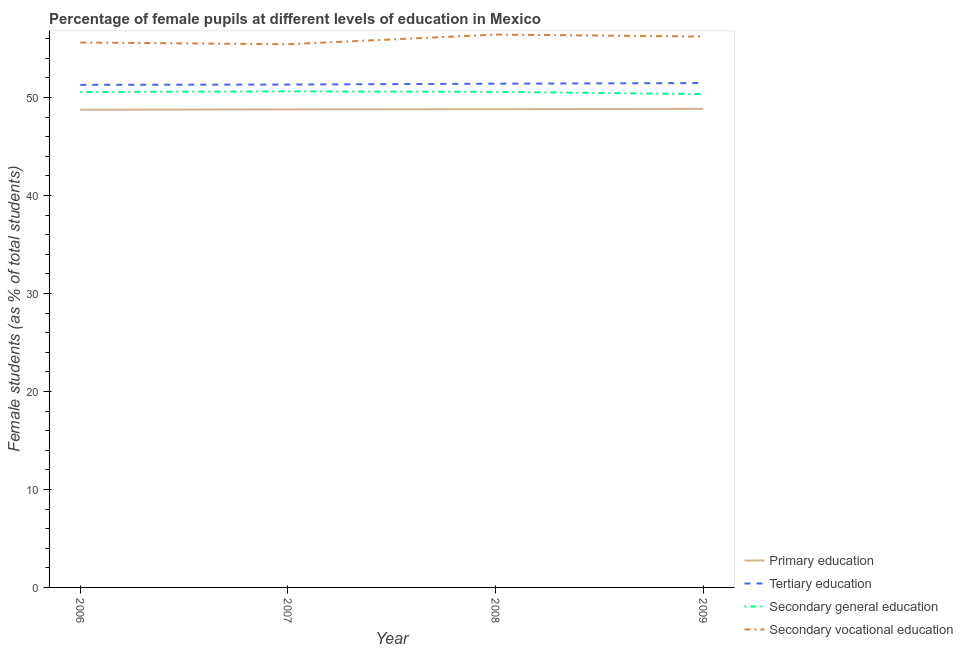How many different coloured lines are there?
Keep it short and to the point. 4. What is the percentage of female students in secondary education in 2008?
Provide a succinct answer. 50.57. Across all years, what is the maximum percentage of female students in tertiary education?
Provide a short and direct response. 51.46. Across all years, what is the minimum percentage of female students in secondary education?
Make the answer very short. 50.34. In which year was the percentage of female students in primary education maximum?
Provide a succinct answer. 2009. What is the total percentage of female students in tertiary education in the graph?
Offer a very short reply. 205.46. What is the difference between the percentage of female students in tertiary education in 2008 and that in 2009?
Make the answer very short. -0.07. What is the difference between the percentage of female students in primary education in 2006 and the percentage of female students in secondary vocational education in 2008?
Provide a short and direct response. -7.67. What is the average percentage of female students in tertiary education per year?
Your answer should be very brief. 51.36. In the year 2009, what is the difference between the percentage of female students in primary education and percentage of female students in secondary education?
Give a very brief answer. -1.51. In how many years, is the percentage of female students in secondary vocational education greater than 36 %?
Give a very brief answer. 4. What is the ratio of the percentage of female students in secondary education in 2007 to that in 2008?
Offer a terse response. 1. Is the difference between the percentage of female students in secondary vocational education in 2006 and 2007 greater than the difference between the percentage of female students in tertiary education in 2006 and 2007?
Your answer should be very brief. Yes. What is the difference between the highest and the second highest percentage of female students in tertiary education?
Ensure brevity in your answer.  0.07. What is the difference between the highest and the lowest percentage of female students in secondary education?
Give a very brief answer. 0.28. Is it the case that in every year, the sum of the percentage of female students in primary education and percentage of female students in tertiary education is greater than the percentage of female students in secondary education?
Your answer should be very brief. Yes. Does the percentage of female students in tertiary education monotonically increase over the years?
Your answer should be compact. Yes. Is the percentage of female students in primary education strictly greater than the percentage of female students in tertiary education over the years?
Ensure brevity in your answer.  No. Is the percentage of female students in primary education strictly less than the percentage of female students in secondary vocational education over the years?
Your answer should be very brief. Yes. How many lines are there?
Offer a terse response. 4. Where does the legend appear in the graph?
Offer a very short reply. Bottom right. How many legend labels are there?
Your response must be concise. 4. What is the title of the graph?
Your response must be concise. Percentage of female pupils at different levels of education in Mexico. What is the label or title of the X-axis?
Offer a terse response. Year. What is the label or title of the Y-axis?
Offer a very short reply. Female students (as % of total students). What is the Female students (as % of total students) in Primary education in 2006?
Offer a terse response. 48.74. What is the Female students (as % of total students) of Tertiary education in 2006?
Offer a very short reply. 51.28. What is the Female students (as % of total students) in Secondary general education in 2006?
Your answer should be compact. 50.55. What is the Female students (as % of total students) of Secondary vocational education in 2006?
Offer a very short reply. 55.6. What is the Female students (as % of total students) of Primary education in 2007?
Offer a terse response. 48.78. What is the Female students (as % of total students) of Tertiary education in 2007?
Provide a short and direct response. 51.31. What is the Female students (as % of total students) of Secondary general education in 2007?
Offer a terse response. 50.62. What is the Female students (as % of total students) of Secondary vocational education in 2007?
Provide a short and direct response. 55.43. What is the Female students (as % of total students) of Primary education in 2008?
Offer a very short reply. 48.8. What is the Female students (as % of total students) in Tertiary education in 2008?
Give a very brief answer. 51.4. What is the Female students (as % of total students) of Secondary general education in 2008?
Ensure brevity in your answer.  50.57. What is the Female students (as % of total students) of Secondary vocational education in 2008?
Give a very brief answer. 56.41. What is the Female students (as % of total students) of Primary education in 2009?
Ensure brevity in your answer.  48.83. What is the Female students (as % of total students) in Tertiary education in 2009?
Give a very brief answer. 51.46. What is the Female students (as % of total students) in Secondary general education in 2009?
Offer a very short reply. 50.34. What is the Female students (as % of total students) of Secondary vocational education in 2009?
Your response must be concise. 56.21. Across all years, what is the maximum Female students (as % of total students) in Primary education?
Provide a succinct answer. 48.83. Across all years, what is the maximum Female students (as % of total students) in Tertiary education?
Provide a succinct answer. 51.46. Across all years, what is the maximum Female students (as % of total students) of Secondary general education?
Your answer should be very brief. 50.62. Across all years, what is the maximum Female students (as % of total students) of Secondary vocational education?
Make the answer very short. 56.41. Across all years, what is the minimum Female students (as % of total students) of Primary education?
Make the answer very short. 48.74. Across all years, what is the minimum Female students (as % of total students) of Tertiary education?
Give a very brief answer. 51.28. Across all years, what is the minimum Female students (as % of total students) in Secondary general education?
Your response must be concise. 50.34. Across all years, what is the minimum Female students (as % of total students) of Secondary vocational education?
Ensure brevity in your answer.  55.43. What is the total Female students (as % of total students) of Primary education in the graph?
Offer a terse response. 195.15. What is the total Female students (as % of total students) of Tertiary education in the graph?
Your answer should be compact. 205.46. What is the total Female students (as % of total students) in Secondary general education in the graph?
Give a very brief answer. 202.08. What is the total Female students (as % of total students) of Secondary vocational education in the graph?
Provide a succinct answer. 223.65. What is the difference between the Female students (as % of total students) of Primary education in 2006 and that in 2007?
Make the answer very short. -0.04. What is the difference between the Female students (as % of total students) of Tertiary education in 2006 and that in 2007?
Give a very brief answer. -0.03. What is the difference between the Female students (as % of total students) in Secondary general education in 2006 and that in 2007?
Offer a terse response. -0.07. What is the difference between the Female students (as % of total students) in Secondary vocational education in 2006 and that in 2007?
Your answer should be very brief. 0.17. What is the difference between the Female students (as % of total students) in Primary education in 2006 and that in 2008?
Ensure brevity in your answer.  -0.06. What is the difference between the Female students (as % of total students) of Tertiary education in 2006 and that in 2008?
Ensure brevity in your answer.  -0.12. What is the difference between the Female students (as % of total students) in Secondary general education in 2006 and that in 2008?
Give a very brief answer. -0.01. What is the difference between the Female students (as % of total students) of Secondary vocational education in 2006 and that in 2008?
Your answer should be very brief. -0.81. What is the difference between the Female students (as % of total students) in Primary education in 2006 and that in 2009?
Provide a short and direct response. -0.09. What is the difference between the Female students (as % of total students) in Tertiary education in 2006 and that in 2009?
Your answer should be compact. -0.18. What is the difference between the Female students (as % of total students) of Secondary general education in 2006 and that in 2009?
Your answer should be compact. 0.21. What is the difference between the Female students (as % of total students) in Secondary vocational education in 2006 and that in 2009?
Provide a succinct answer. -0.61. What is the difference between the Female students (as % of total students) of Primary education in 2007 and that in 2008?
Your answer should be very brief. -0.02. What is the difference between the Female students (as % of total students) in Tertiary education in 2007 and that in 2008?
Ensure brevity in your answer.  -0.09. What is the difference between the Female students (as % of total students) of Secondary general education in 2007 and that in 2008?
Provide a short and direct response. 0.05. What is the difference between the Female students (as % of total students) of Secondary vocational education in 2007 and that in 2008?
Offer a very short reply. -0.98. What is the difference between the Female students (as % of total students) of Primary education in 2007 and that in 2009?
Make the answer very short. -0.05. What is the difference between the Female students (as % of total students) in Tertiary education in 2007 and that in 2009?
Your answer should be compact. -0.15. What is the difference between the Female students (as % of total students) of Secondary general education in 2007 and that in 2009?
Give a very brief answer. 0.28. What is the difference between the Female students (as % of total students) in Secondary vocational education in 2007 and that in 2009?
Provide a short and direct response. -0.78. What is the difference between the Female students (as % of total students) in Primary education in 2008 and that in 2009?
Keep it short and to the point. -0.03. What is the difference between the Female students (as % of total students) in Tertiary education in 2008 and that in 2009?
Your answer should be very brief. -0.07. What is the difference between the Female students (as % of total students) of Secondary general education in 2008 and that in 2009?
Your answer should be compact. 0.23. What is the difference between the Female students (as % of total students) of Secondary vocational education in 2008 and that in 2009?
Your response must be concise. 0.2. What is the difference between the Female students (as % of total students) of Primary education in 2006 and the Female students (as % of total students) of Tertiary education in 2007?
Give a very brief answer. -2.57. What is the difference between the Female students (as % of total students) of Primary education in 2006 and the Female students (as % of total students) of Secondary general education in 2007?
Your answer should be compact. -1.88. What is the difference between the Female students (as % of total students) of Primary education in 2006 and the Female students (as % of total students) of Secondary vocational education in 2007?
Your answer should be compact. -6.68. What is the difference between the Female students (as % of total students) in Tertiary education in 2006 and the Female students (as % of total students) in Secondary general education in 2007?
Offer a very short reply. 0.66. What is the difference between the Female students (as % of total students) in Tertiary education in 2006 and the Female students (as % of total students) in Secondary vocational education in 2007?
Offer a very short reply. -4.15. What is the difference between the Female students (as % of total students) of Secondary general education in 2006 and the Female students (as % of total students) of Secondary vocational education in 2007?
Make the answer very short. -4.87. What is the difference between the Female students (as % of total students) in Primary education in 2006 and the Female students (as % of total students) in Tertiary education in 2008?
Ensure brevity in your answer.  -2.66. What is the difference between the Female students (as % of total students) in Primary education in 2006 and the Female students (as % of total students) in Secondary general education in 2008?
Keep it short and to the point. -1.82. What is the difference between the Female students (as % of total students) of Primary education in 2006 and the Female students (as % of total students) of Secondary vocational education in 2008?
Ensure brevity in your answer.  -7.67. What is the difference between the Female students (as % of total students) of Tertiary education in 2006 and the Female students (as % of total students) of Secondary general education in 2008?
Your answer should be very brief. 0.71. What is the difference between the Female students (as % of total students) of Tertiary education in 2006 and the Female students (as % of total students) of Secondary vocational education in 2008?
Make the answer very short. -5.13. What is the difference between the Female students (as % of total students) in Secondary general education in 2006 and the Female students (as % of total students) in Secondary vocational education in 2008?
Offer a very short reply. -5.86. What is the difference between the Female students (as % of total students) of Primary education in 2006 and the Female students (as % of total students) of Tertiary education in 2009?
Make the answer very short. -2.72. What is the difference between the Female students (as % of total students) in Primary education in 2006 and the Female students (as % of total students) in Secondary general education in 2009?
Your answer should be compact. -1.6. What is the difference between the Female students (as % of total students) in Primary education in 2006 and the Female students (as % of total students) in Secondary vocational education in 2009?
Offer a terse response. -7.47. What is the difference between the Female students (as % of total students) in Tertiary education in 2006 and the Female students (as % of total students) in Secondary general education in 2009?
Offer a very short reply. 0.94. What is the difference between the Female students (as % of total students) of Tertiary education in 2006 and the Female students (as % of total students) of Secondary vocational education in 2009?
Your answer should be very brief. -4.93. What is the difference between the Female students (as % of total students) of Secondary general education in 2006 and the Female students (as % of total students) of Secondary vocational education in 2009?
Provide a short and direct response. -5.66. What is the difference between the Female students (as % of total students) of Primary education in 2007 and the Female students (as % of total students) of Tertiary education in 2008?
Offer a very short reply. -2.62. What is the difference between the Female students (as % of total students) of Primary education in 2007 and the Female students (as % of total students) of Secondary general education in 2008?
Your response must be concise. -1.79. What is the difference between the Female students (as % of total students) of Primary education in 2007 and the Female students (as % of total students) of Secondary vocational education in 2008?
Offer a terse response. -7.63. What is the difference between the Female students (as % of total students) of Tertiary education in 2007 and the Female students (as % of total students) of Secondary general education in 2008?
Make the answer very short. 0.75. What is the difference between the Female students (as % of total students) of Tertiary education in 2007 and the Female students (as % of total students) of Secondary vocational education in 2008?
Keep it short and to the point. -5.1. What is the difference between the Female students (as % of total students) of Secondary general education in 2007 and the Female students (as % of total students) of Secondary vocational education in 2008?
Keep it short and to the point. -5.79. What is the difference between the Female students (as % of total students) of Primary education in 2007 and the Female students (as % of total students) of Tertiary education in 2009?
Keep it short and to the point. -2.69. What is the difference between the Female students (as % of total students) of Primary education in 2007 and the Female students (as % of total students) of Secondary general education in 2009?
Provide a succinct answer. -1.56. What is the difference between the Female students (as % of total students) in Primary education in 2007 and the Female students (as % of total students) in Secondary vocational education in 2009?
Ensure brevity in your answer.  -7.43. What is the difference between the Female students (as % of total students) of Tertiary education in 2007 and the Female students (as % of total students) of Secondary general education in 2009?
Offer a terse response. 0.97. What is the difference between the Female students (as % of total students) of Tertiary education in 2007 and the Female students (as % of total students) of Secondary vocational education in 2009?
Give a very brief answer. -4.9. What is the difference between the Female students (as % of total students) of Secondary general education in 2007 and the Female students (as % of total students) of Secondary vocational education in 2009?
Give a very brief answer. -5.59. What is the difference between the Female students (as % of total students) in Primary education in 2008 and the Female students (as % of total students) in Tertiary education in 2009?
Your response must be concise. -2.67. What is the difference between the Female students (as % of total students) of Primary education in 2008 and the Female students (as % of total students) of Secondary general education in 2009?
Ensure brevity in your answer.  -1.54. What is the difference between the Female students (as % of total students) in Primary education in 2008 and the Female students (as % of total students) in Secondary vocational education in 2009?
Your answer should be very brief. -7.41. What is the difference between the Female students (as % of total students) of Tertiary education in 2008 and the Female students (as % of total students) of Secondary general education in 2009?
Your answer should be compact. 1.06. What is the difference between the Female students (as % of total students) in Tertiary education in 2008 and the Female students (as % of total students) in Secondary vocational education in 2009?
Offer a very short reply. -4.81. What is the difference between the Female students (as % of total students) of Secondary general education in 2008 and the Female students (as % of total students) of Secondary vocational education in 2009?
Give a very brief answer. -5.64. What is the average Female students (as % of total students) of Primary education per year?
Provide a succinct answer. 48.79. What is the average Female students (as % of total students) of Tertiary education per year?
Your answer should be very brief. 51.36. What is the average Female students (as % of total students) in Secondary general education per year?
Your answer should be compact. 50.52. What is the average Female students (as % of total students) in Secondary vocational education per year?
Your response must be concise. 55.91. In the year 2006, what is the difference between the Female students (as % of total students) of Primary education and Female students (as % of total students) of Tertiary education?
Keep it short and to the point. -2.54. In the year 2006, what is the difference between the Female students (as % of total students) of Primary education and Female students (as % of total students) of Secondary general education?
Your answer should be very brief. -1.81. In the year 2006, what is the difference between the Female students (as % of total students) in Primary education and Female students (as % of total students) in Secondary vocational education?
Provide a succinct answer. -6.86. In the year 2006, what is the difference between the Female students (as % of total students) in Tertiary education and Female students (as % of total students) in Secondary general education?
Offer a terse response. 0.73. In the year 2006, what is the difference between the Female students (as % of total students) of Tertiary education and Female students (as % of total students) of Secondary vocational education?
Offer a terse response. -4.32. In the year 2006, what is the difference between the Female students (as % of total students) in Secondary general education and Female students (as % of total students) in Secondary vocational education?
Your answer should be very brief. -5.05. In the year 2007, what is the difference between the Female students (as % of total students) of Primary education and Female students (as % of total students) of Tertiary education?
Give a very brief answer. -2.53. In the year 2007, what is the difference between the Female students (as % of total students) in Primary education and Female students (as % of total students) in Secondary general education?
Make the answer very short. -1.84. In the year 2007, what is the difference between the Female students (as % of total students) in Primary education and Female students (as % of total students) in Secondary vocational education?
Your answer should be very brief. -6.65. In the year 2007, what is the difference between the Female students (as % of total students) in Tertiary education and Female students (as % of total students) in Secondary general education?
Provide a short and direct response. 0.69. In the year 2007, what is the difference between the Female students (as % of total students) of Tertiary education and Female students (as % of total students) of Secondary vocational education?
Ensure brevity in your answer.  -4.11. In the year 2007, what is the difference between the Female students (as % of total students) in Secondary general education and Female students (as % of total students) in Secondary vocational education?
Ensure brevity in your answer.  -4.81. In the year 2008, what is the difference between the Female students (as % of total students) in Primary education and Female students (as % of total students) in Tertiary education?
Offer a very short reply. -2.6. In the year 2008, what is the difference between the Female students (as % of total students) in Primary education and Female students (as % of total students) in Secondary general education?
Give a very brief answer. -1.77. In the year 2008, what is the difference between the Female students (as % of total students) in Primary education and Female students (as % of total students) in Secondary vocational education?
Keep it short and to the point. -7.61. In the year 2008, what is the difference between the Female students (as % of total students) in Tertiary education and Female students (as % of total students) in Secondary general education?
Provide a succinct answer. 0.83. In the year 2008, what is the difference between the Female students (as % of total students) of Tertiary education and Female students (as % of total students) of Secondary vocational education?
Offer a very short reply. -5.01. In the year 2008, what is the difference between the Female students (as % of total students) in Secondary general education and Female students (as % of total students) in Secondary vocational education?
Offer a very short reply. -5.84. In the year 2009, what is the difference between the Female students (as % of total students) of Primary education and Female students (as % of total students) of Tertiary education?
Provide a succinct answer. -2.63. In the year 2009, what is the difference between the Female students (as % of total students) of Primary education and Female students (as % of total students) of Secondary general education?
Your response must be concise. -1.51. In the year 2009, what is the difference between the Female students (as % of total students) of Primary education and Female students (as % of total students) of Secondary vocational education?
Provide a short and direct response. -7.38. In the year 2009, what is the difference between the Female students (as % of total students) in Tertiary education and Female students (as % of total students) in Secondary general education?
Offer a terse response. 1.13. In the year 2009, what is the difference between the Female students (as % of total students) in Tertiary education and Female students (as % of total students) in Secondary vocational education?
Make the answer very short. -4.75. In the year 2009, what is the difference between the Female students (as % of total students) of Secondary general education and Female students (as % of total students) of Secondary vocational education?
Provide a short and direct response. -5.87. What is the ratio of the Female students (as % of total students) in Tertiary education in 2006 to that in 2007?
Make the answer very short. 1. What is the ratio of the Female students (as % of total students) in Secondary general education in 2006 to that in 2007?
Your answer should be very brief. 1. What is the ratio of the Female students (as % of total students) of Secondary vocational education in 2006 to that in 2007?
Offer a terse response. 1. What is the ratio of the Female students (as % of total students) in Secondary vocational education in 2006 to that in 2008?
Offer a very short reply. 0.99. What is the ratio of the Female students (as % of total students) of Tertiary education in 2006 to that in 2009?
Keep it short and to the point. 1. What is the ratio of the Female students (as % of total students) in Secondary general education in 2006 to that in 2009?
Offer a terse response. 1. What is the ratio of the Female students (as % of total students) in Primary education in 2007 to that in 2008?
Provide a short and direct response. 1. What is the ratio of the Female students (as % of total students) in Secondary general education in 2007 to that in 2008?
Your response must be concise. 1. What is the ratio of the Female students (as % of total students) in Secondary vocational education in 2007 to that in 2008?
Your answer should be very brief. 0.98. What is the ratio of the Female students (as % of total students) in Tertiary education in 2007 to that in 2009?
Ensure brevity in your answer.  1. What is the ratio of the Female students (as % of total students) in Secondary general education in 2007 to that in 2009?
Give a very brief answer. 1.01. What is the ratio of the Female students (as % of total students) in Secondary vocational education in 2007 to that in 2009?
Ensure brevity in your answer.  0.99. What is the ratio of the Female students (as % of total students) of Primary education in 2008 to that in 2009?
Your response must be concise. 1. What is the difference between the highest and the second highest Female students (as % of total students) in Primary education?
Give a very brief answer. 0.03. What is the difference between the highest and the second highest Female students (as % of total students) of Tertiary education?
Keep it short and to the point. 0.07. What is the difference between the highest and the second highest Female students (as % of total students) in Secondary general education?
Keep it short and to the point. 0.05. What is the difference between the highest and the second highest Female students (as % of total students) in Secondary vocational education?
Ensure brevity in your answer.  0.2. What is the difference between the highest and the lowest Female students (as % of total students) of Primary education?
Make the answer very short. 0.09. What is the difference between the highest and the lowest Female students (as % of total students) of Tertiary education?
Make the answer very short. 0.18. What is the difference between the highest and the lowest Female students (as % of total students) in Secondary general education?
Your answer should be compact. 0.28. What is the difference between the highest and the lowest Female students (as % of total students) of Secondary vocational education?
Keep it short and to the point. 0.98. 